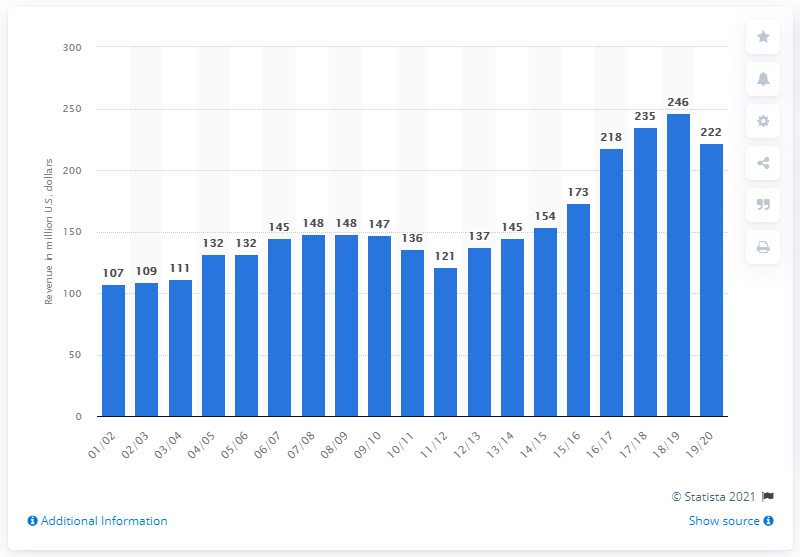Give some essential details in this illustration. The estimated revenue of the Phoenix Suns in the 2019/2020 season was approximately 222 million dollars. 